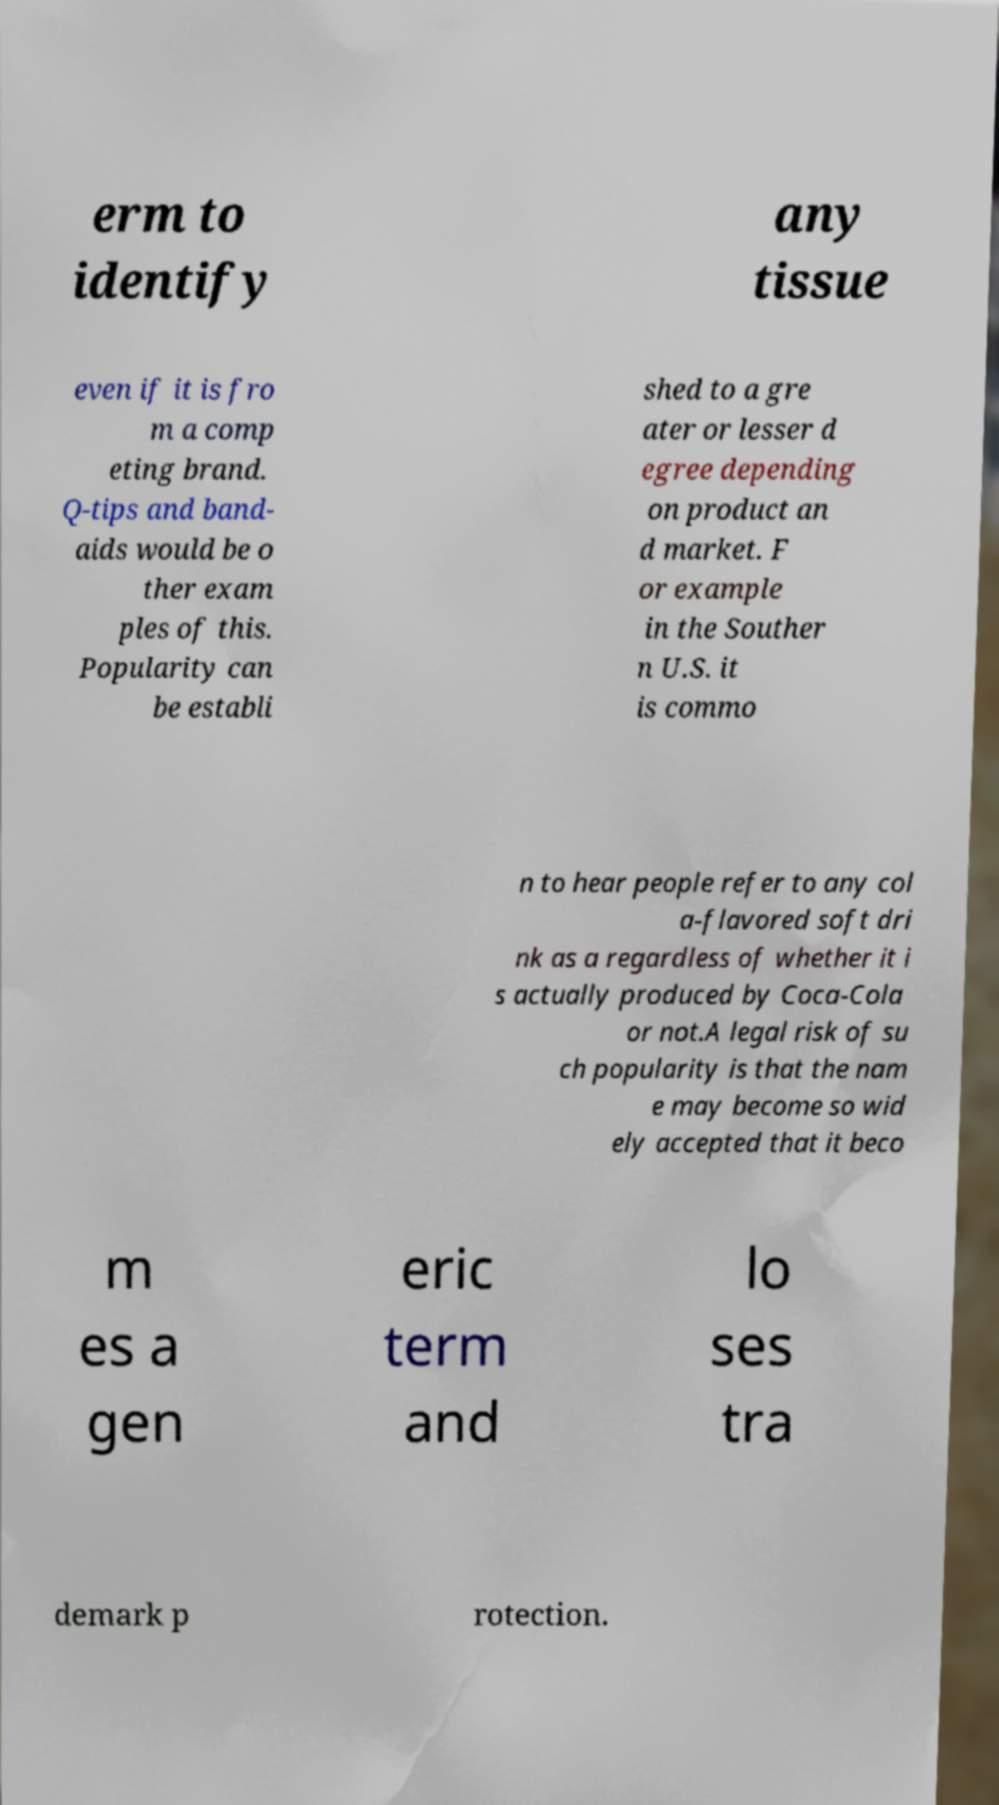Could you extract and type out the text from this image? erm to identify any tissue even if it is fro m a comp eting brand. Q-tips and band- aids would be o ther exam ples of this. Popularity can be establi shed to a gre ater or lesser d egree depending on product an d market. F or example in the Souther n U.S. it is commo n to hear people refer to any col a-flavored soft dri nk as a regardless of whether it i s actually produced by Coca-Cola or not.A legal risk of su ch popularity is that the nam e may become so wid ely accepted that it beco m es a gen eric term and lo ses tra demark p rotection. 